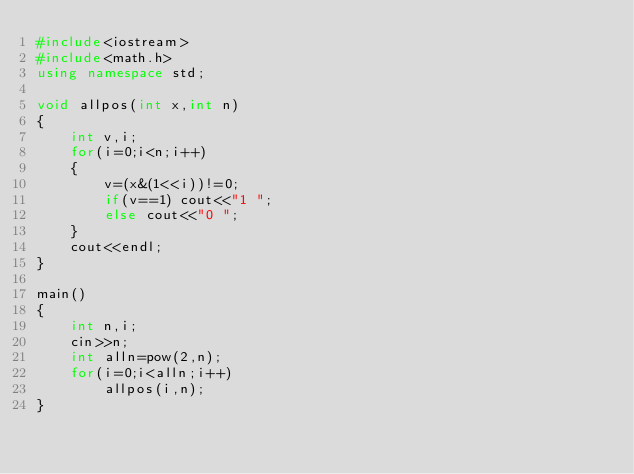Convert code to text. <code><loc_0><loc_0><loc_500><loc_500><_C++_>#include<iostream>
#include<math.h>
using namespace std;

void allpos(int x,int n)
{
	int v,i;
	for(i=0;i<n;i++)
	{
		v=(x&(1<<i))!=0;
		if(v==1) cout<<"1 ";
		else cout<<"0 ";
	}
	cout<<endl;
}

main()
{
	int n,i;
	cin>>n;
	int alln=pow(2,n);
	for(i=0;i<alln;i++)
		allpos(i,n);
}
</code> 